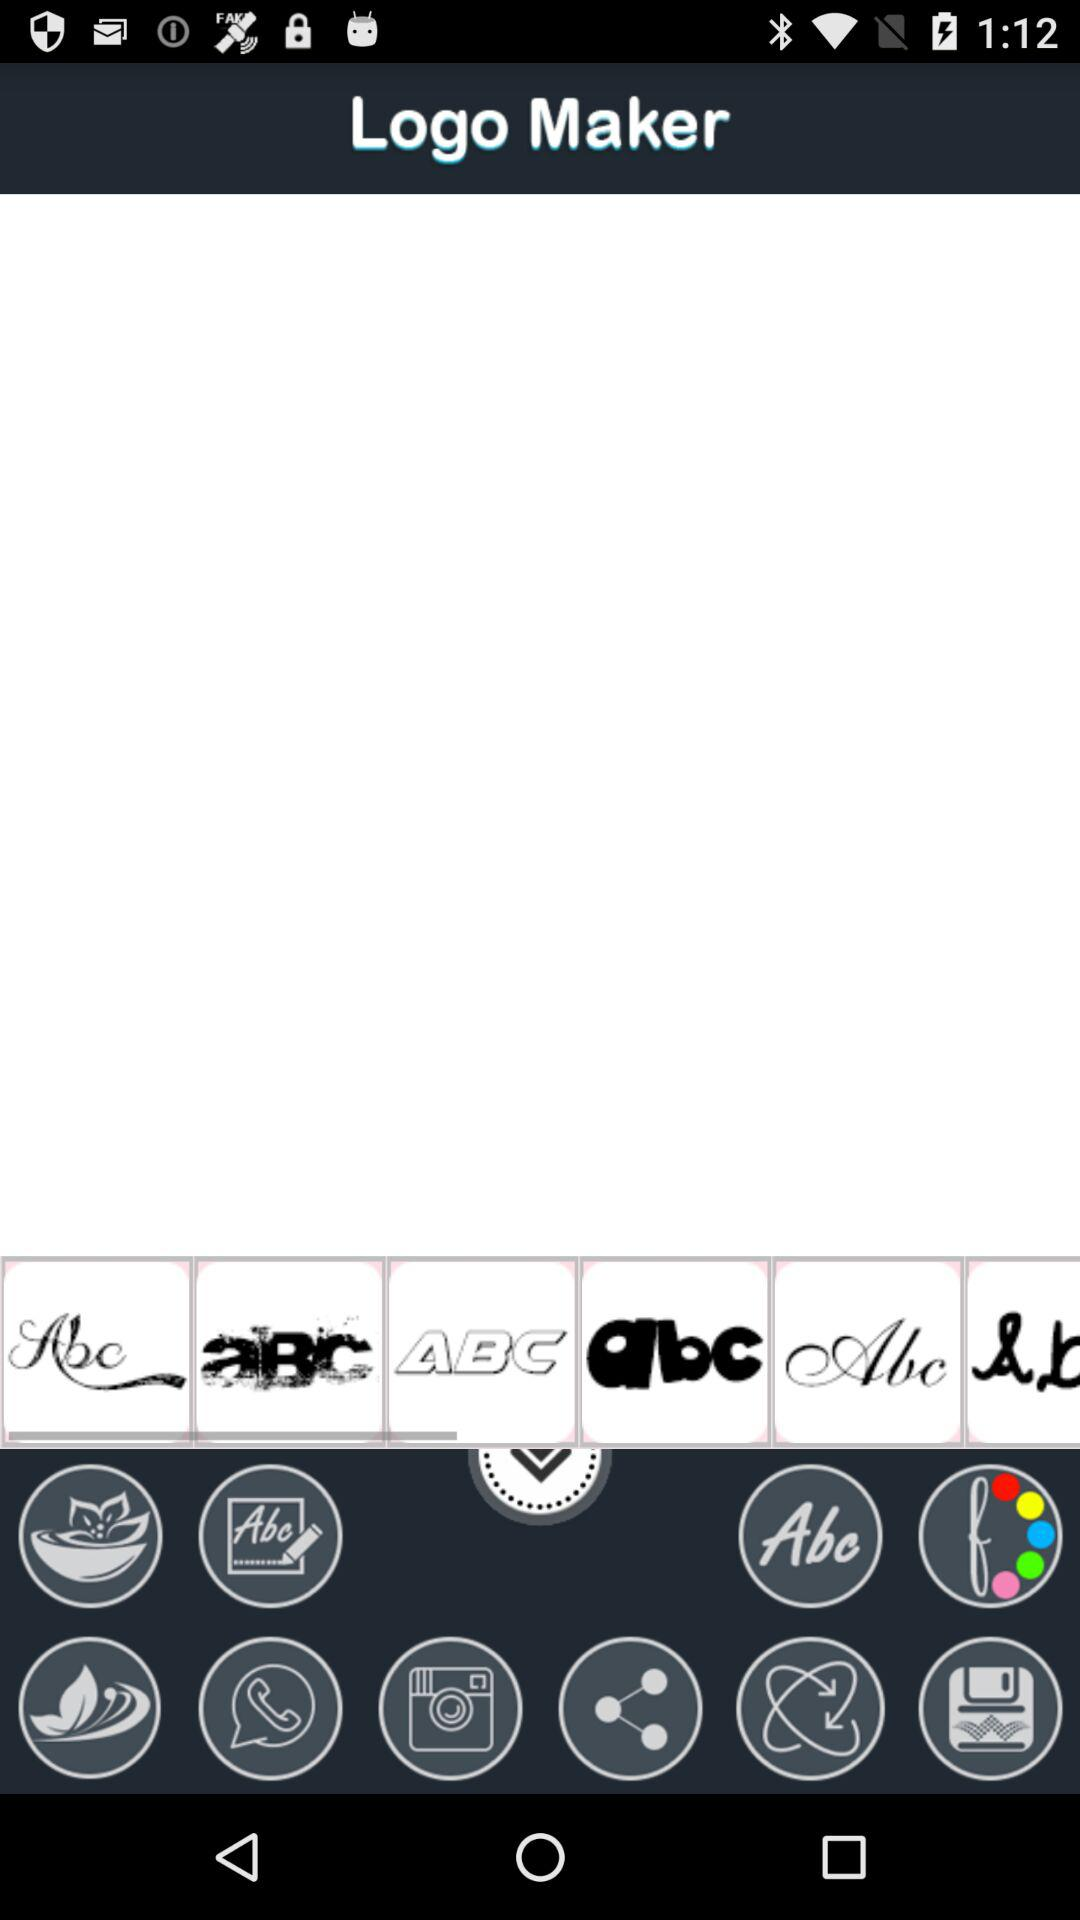What is the name of the application? The name of the application is "Logo Maker". 